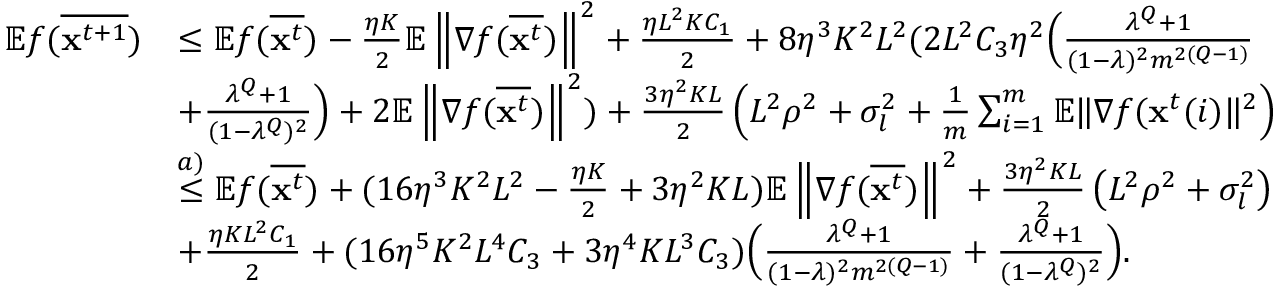Convert formula to latex. <formula><loc_0><loc_0><loc_500><loc_500>\begin{array} { r l } { \mathbb { E } f ( \overline { { x ^ { t + 1 } } } ) } & { \leq \mathbb { E } f ( \overline { { x ^ { t } } } ) - \frac { \eta K } { 2 } \mathbb { E } \left \| \nabla f ( \overline { { x ^ { t } } } ) \right \| ^ { 2 } + \frac { \eta L ^ { 2 } K C _ { 1 } } { 2 } + 8 \eta ^ { 3 } K ^ { 2 } L ^ { 2 } ( 2 L ^ { 2 } C _ { 3 } \eta ^ { 2 } \left ( \frac { \lambda ^ { Q } + 1 } { ( 1 - \lambda ) ^ { 2 } m ^ { 2 ( Q - 1 ) } } } \\ & { + \frac { \lambda ^ { Q } + 1 } { ( 1 - \lambda ^ { Q } ) ^ { 2 } } \right ) + 2 \mathbb { E } \left \| \nabla f ( \overline { { x ^ { t } } } ) \right \| ^ { 2 } ) + \frac { 3 \eta ^ { 2 } K L } { 2 } \left ( L ^ { 2 } \rho ^ { 2 } + \sigma _ { l } ^ { 2 } + \frac { 1 } { m } \sum _ { i = 1 } ^ { m } \mathbb { E } \| \nabla f ( x ^ { t } ( i ) \| ^ { 2 } \right ) } \\ & { \overset { a ) } { \leq } \mathbb { E } f ( \overline { { x ^ { t } } } ) + ( 1 6 \eta ^ { 3 } K ^ { 2 } L ^ { 2 } - \frac { \eta K } { 2 } + 3 \eta ^ { 2 } K L ) \mathbb { E } \left \| \nabla f ( \overline { { x ^ { t } } } ) \right \| ^ { 2 } + \frac { 3 \eta ^ { 2 } K L } { 2 } \left ( L ^ { 2 } \rho ^ { 2 } + \sigma _ { l } ^ { 2 } \right ) } \\ & { + \frac { \eta K L ^ { 2 } C _ { 1 } } { 2 } + ( 1 6 \eta ^ { 5 } K ^ { 2 } L ^ { 4 } C _ { 3 } + 3 \eta ^ { 4 } K L ^ { 3 } C _ { 3 } ) \left ( \frac { \lambda ^ { Q } + 1 } { ( 1 - \lambda ) ^ { 2 } m ^ { 2 ( Q - 1 ) } } + \frac { \lambda ^ { Q } + 1 } { ( 1 - \lambda ^ { Q } ) ^ { 2 } } \right ) . } \end{array}</formula> 